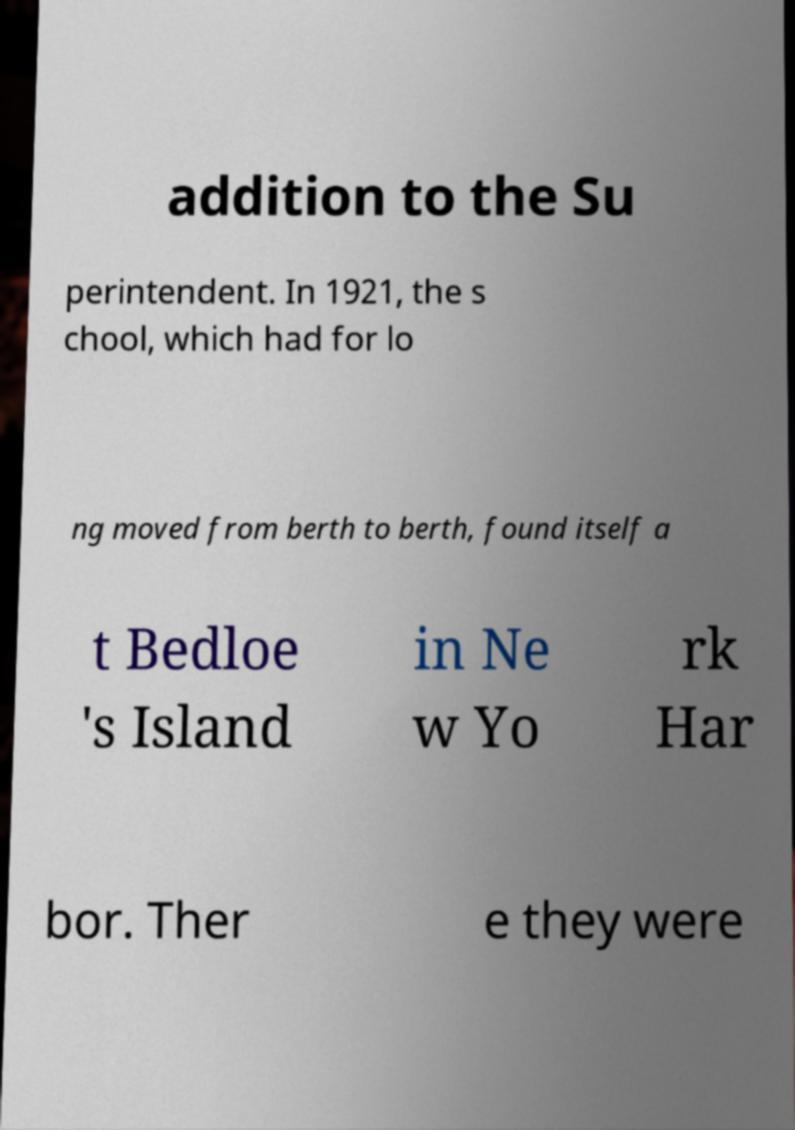What messages or text are displayed in this image? I need them in a readable, typed format. addition to the Su perintendent. In 1921, the s chool, which had for lo ng moved from berth to berth, found itself a t Bedloe 's Island in Ne w Yo rk Har bor. Ther e they were 